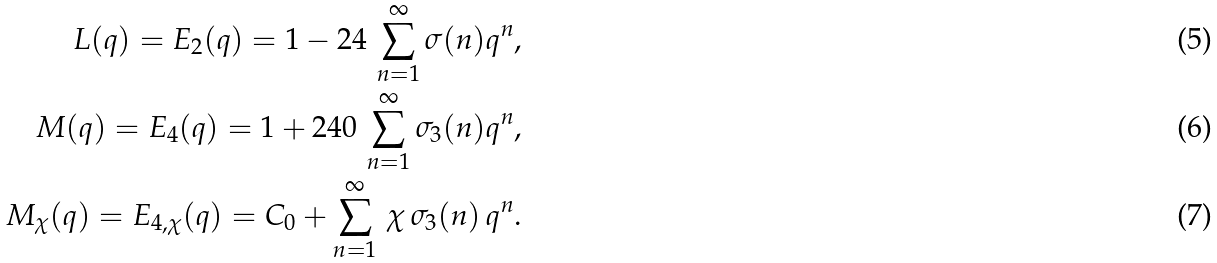Convert formula to latex. <formula><loc_0><loc_0><loc_500><loc_500>L ( q ) = E _ { 2 } ( q ) = 1 - 2 4 \, \sum _ { n = 1 } ^ { \infty } \sigma ( n ) q ^ { n } , \\ M ( q ) = E _ { 4 } ( q ) = 1 + 2 4 0 \, \sum _ { n = 1 } ^ { \infty } \sigma _ { 3 } ( n ) q ^ { n } , \\ M _ { \chi } ( q ) = E _ { 4 , \chi } ( q ) = C _ { 0 } + \sum _ { n = 1 } ^ { \infty } \, \chi \, \sigma _ { 3 } ( n ) \, q ^ { n } .</formula> 